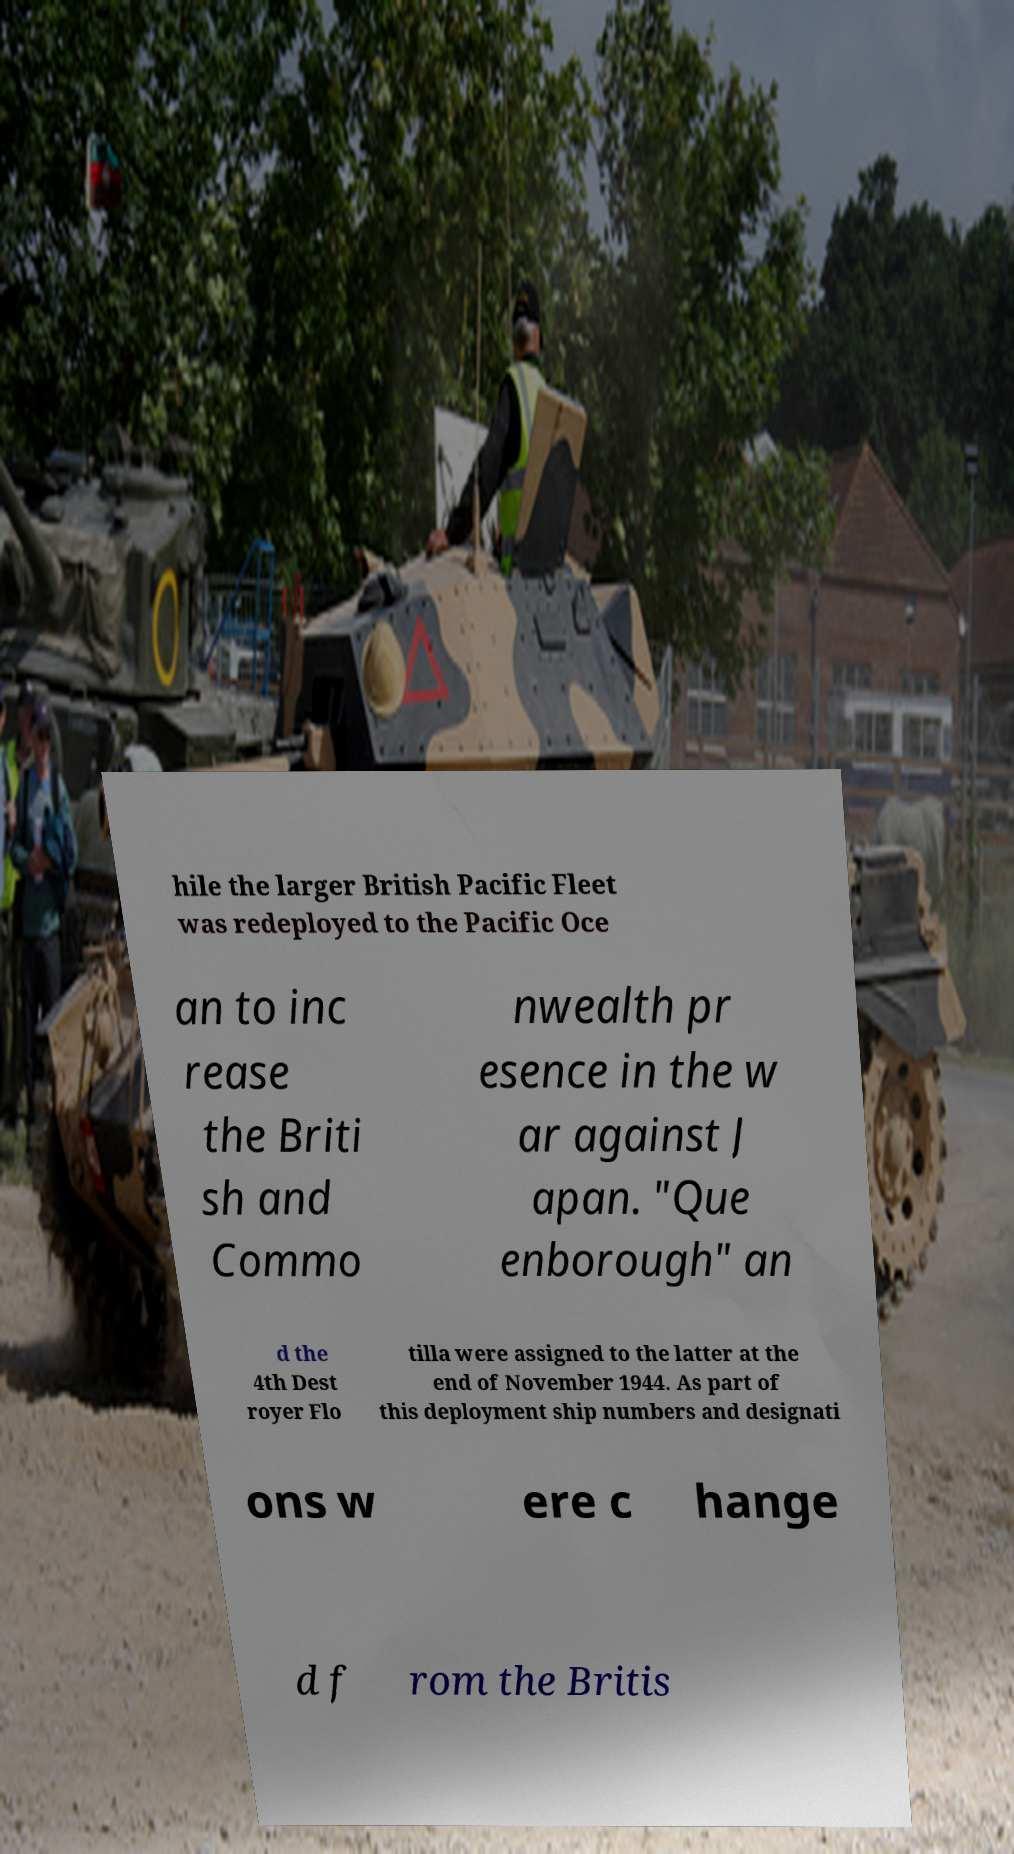Can you accurately transcribe the text from the provided image for me? hile the larger British Pacific Fleet was redeployed to the Pacific Oce an to inc rease the Briti sh and Commo nwealth pr esence in the w ar against J apan. "Que enborough" an d the 4th Dest royer Flo tilla were assigned to the latter at the end of November 1944. As part of this deployment ship numbers and designati ons w ere c hange d f rom the Britis 